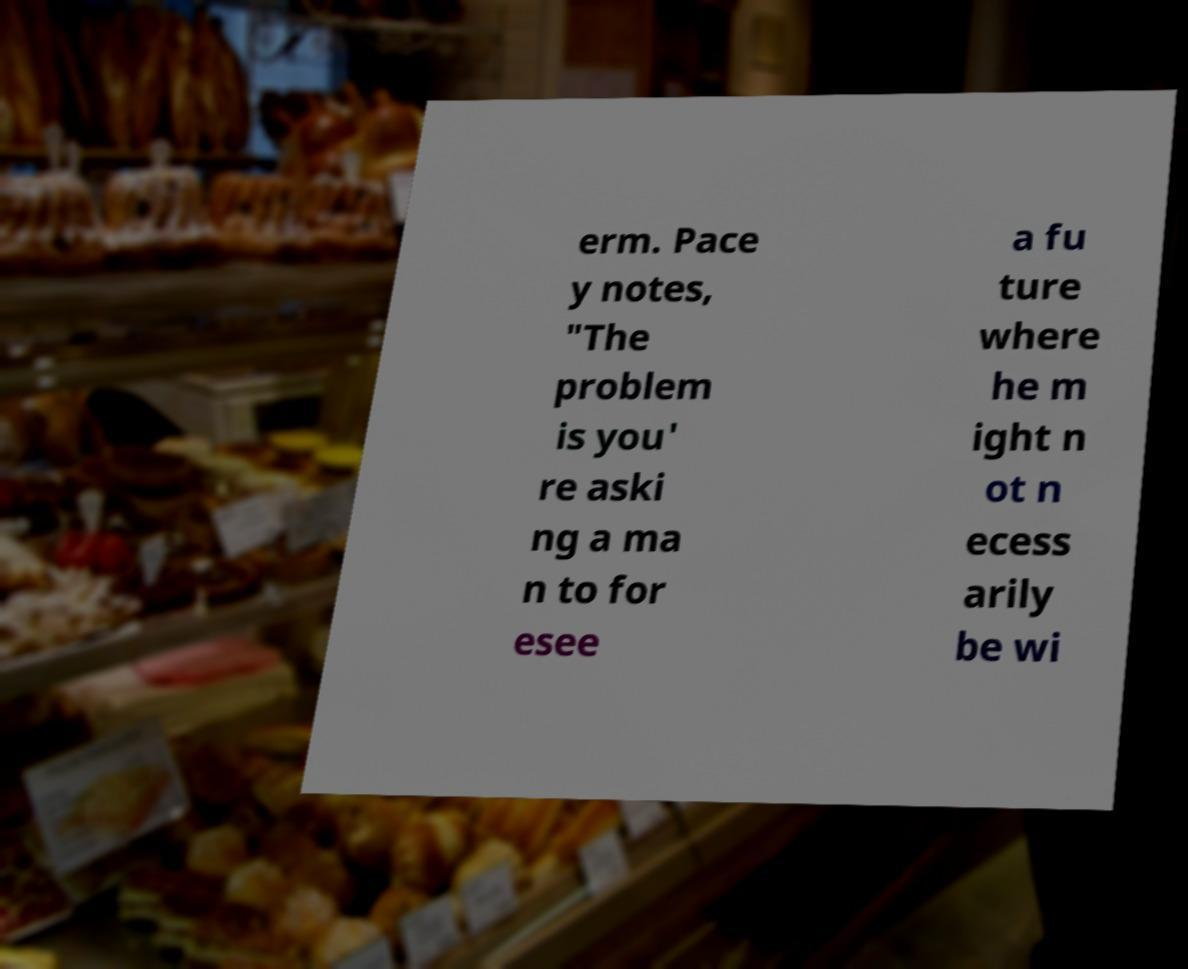For documentation purposes, I need the text within this image transcribed. Could you provide that? erm. Pace y notes, "The problem is you' re aski ng a ma n to for esee a fu ture where he m ight n ot n ecess arily be wi 